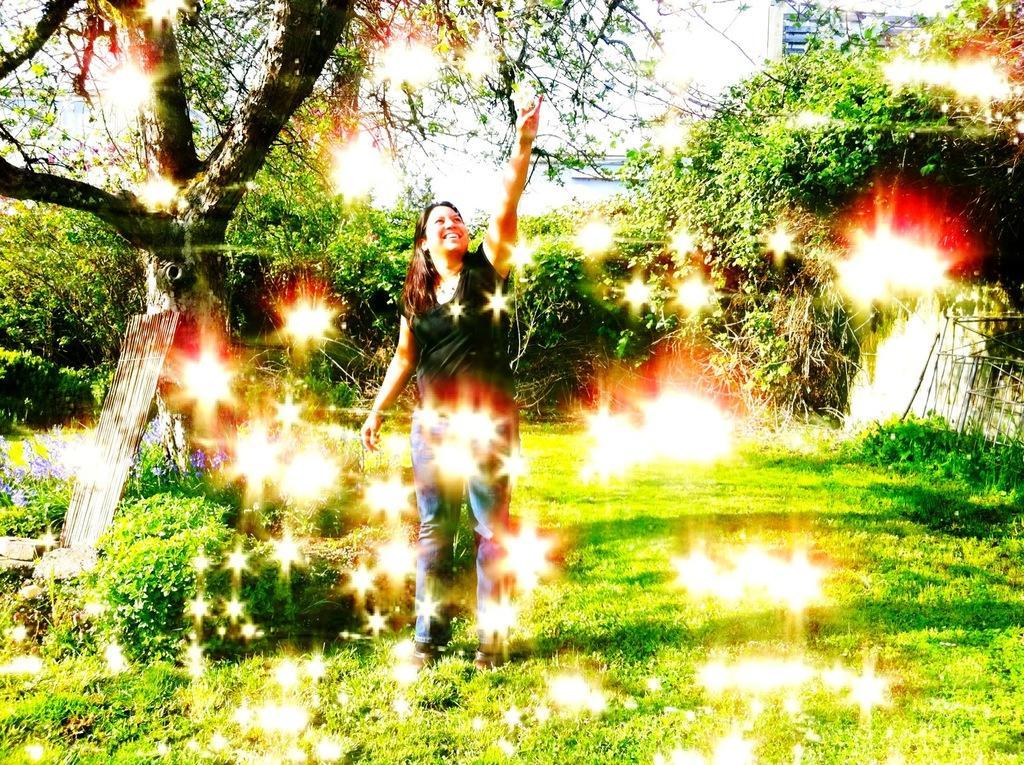Please provide a concise description of this image. In this picture I can see there is a woman standing and laughing, there is some grass on the floor, there are trees in the backdrop and the sky is clear. 